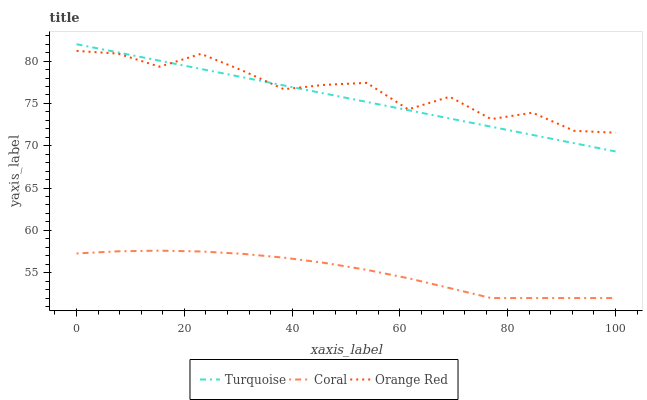Does Coral have the minimum area under the curve?
Answer yes or no. Yes. Does Orange Red have the maximum area under the curve?
Answer yes or no. Yes. Does Orange Red have the minimum area under the curve?
Answer yes or no. No. Does Coral have the maximum area under the curve?
Answer yes or no. No. Is Turquoise the smoothest?
Answer yes or no. Yes. Is Orange Red the roughest?
Answer yes or no. Yes. Is Coral the smoothest?
Answer yes or no. No. Is Coral the roughest?
Answer yes or no. No. Does Coral have the lowest value?
Answer yes or no. Yes. Does Orange Red have the lowest value?
Answer yes or no. No. Does Turquoise have the highest value?
Answer yes or no. Yes. Does Orange Red have the highest value?
Answer yes or no. No. Is Coral less than Turquoise?
Answer yes or no. Yes. Is Orange Red greater than Coral?
Answer yes or no. Yes. Does Orange Red intersect Turquoise?
Answer yes or no. Yes. Is Orange Red less than Turquoise?
Answer yes or no. No. Is Orange Red greater than Turquoise?
Answer yes or no. No. Does Coral intersect Turquoise?
Answer yes or no. No. 